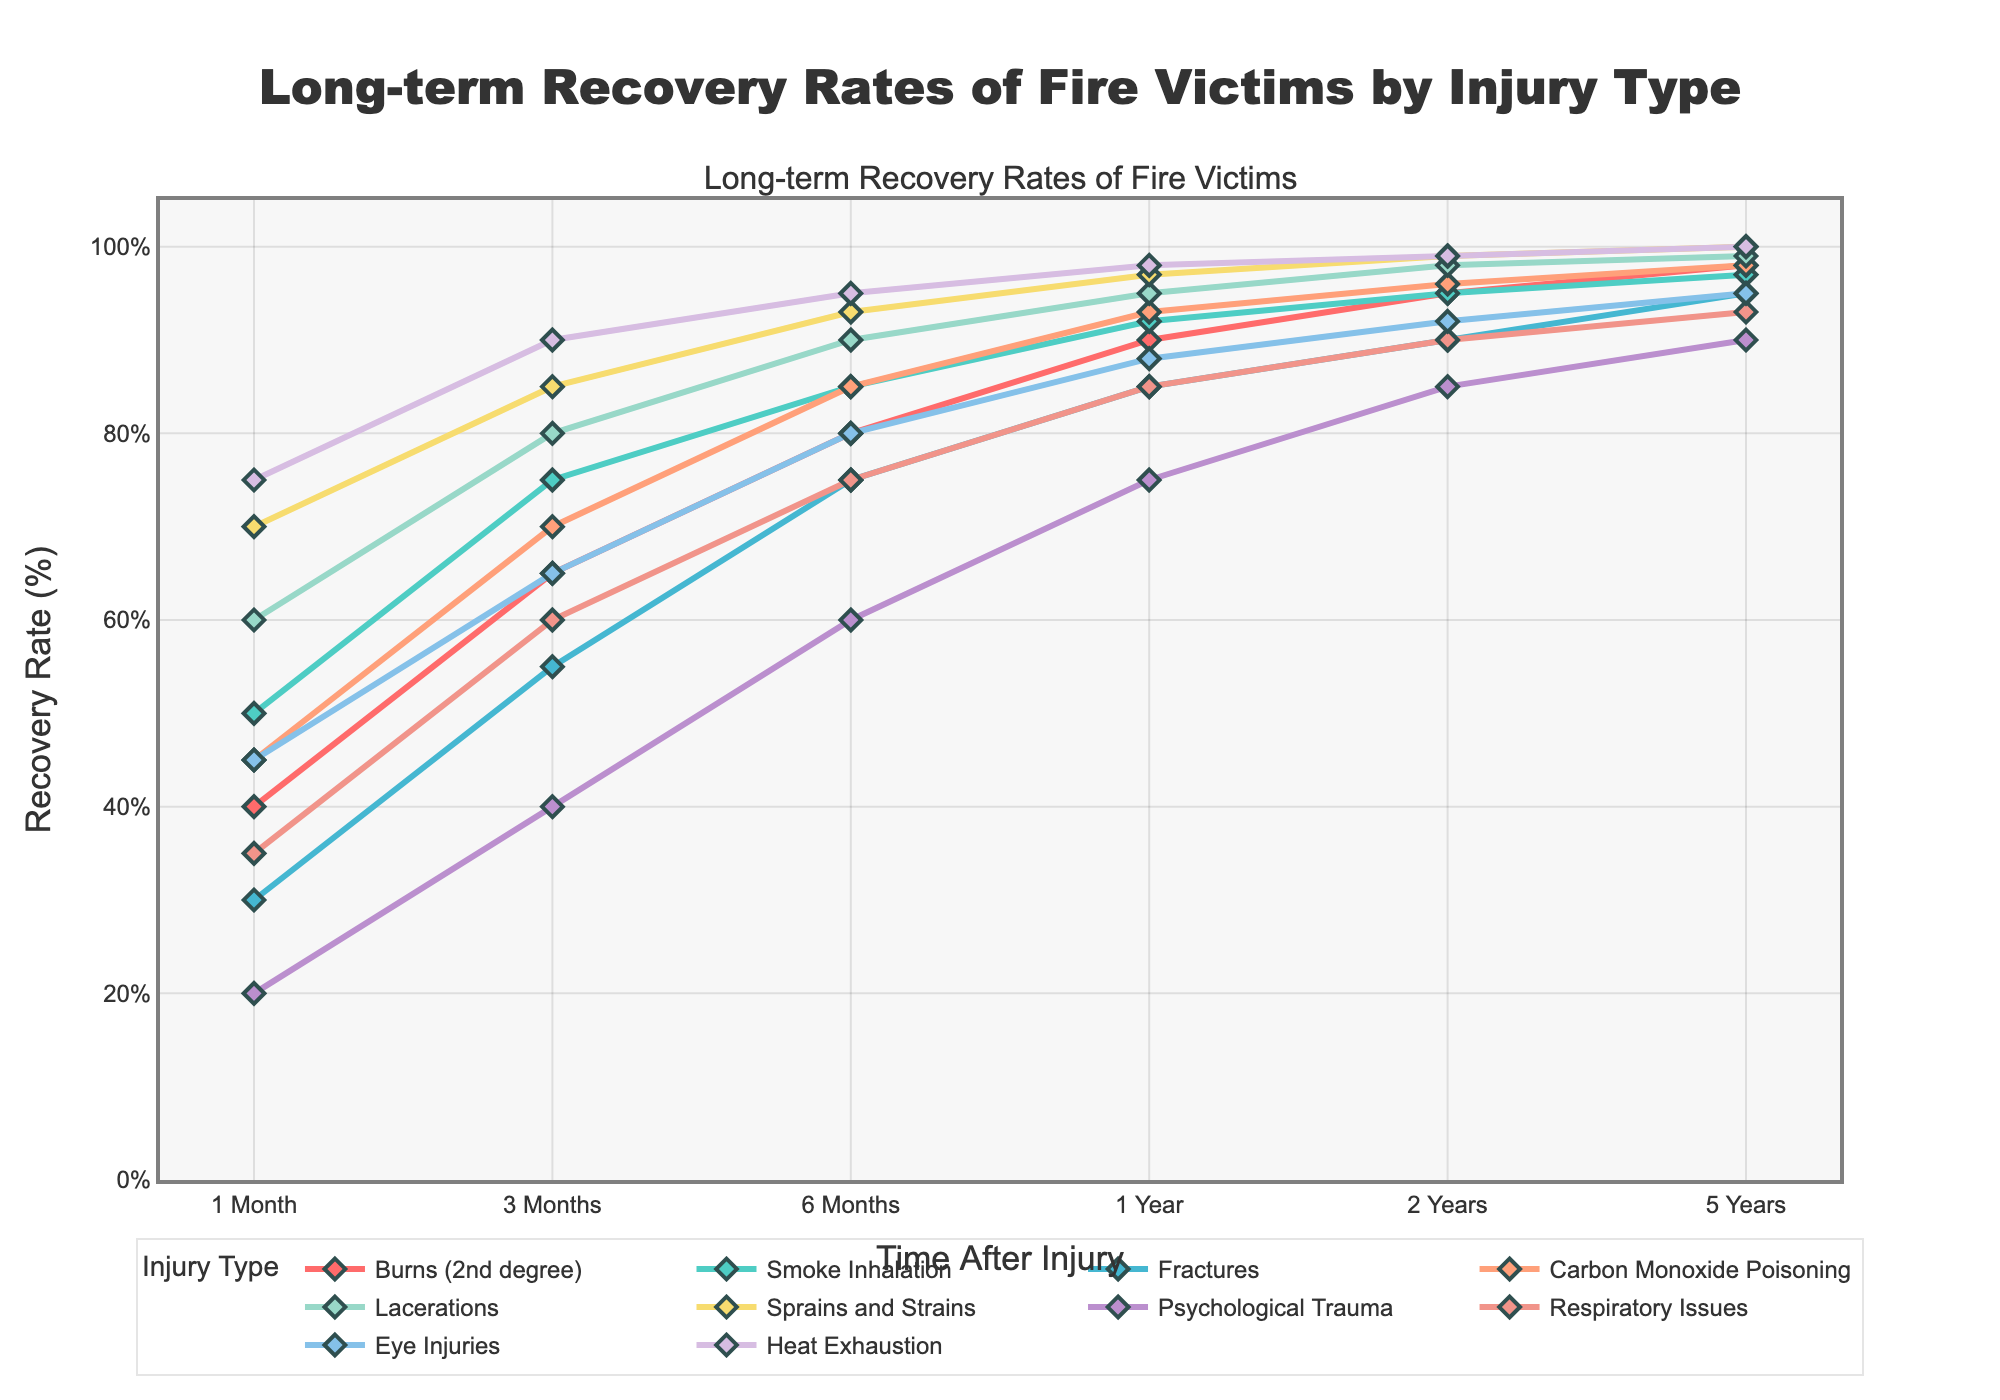What injury type shows the highest recovery rate at the 1-year mark? To answer this, look for the data point with the highest value at the 1-year time interval on the figure. Heat Exhaustion reaches the highest recovery rate at 1 year with 98%.
Answer: Heat Exhaustion Which injury type has the slowest initial recovery rate at 1 month? Find the injury type with the lowest value at the 1-month mark by comparing all the initial points on the figure. Psychological Trauma has the lowest initial recovery rate at 1 month with 20%.
Answer: Psychological Trauma By what percentage does the recovery rate of Psychological Trauma increase from the 1-month to the 1-year mark? Subtract the 1-month recovery rate (20%) from the 1-year recovery rate (75%) for Psychological Trauma to find the increase. The recovery rate increases by 75% - 20% = 55%.
Answer: 55% Which two injury types have the same recovery rate at 2 years? Identify injury types with overlapping points at the 2-year mark. Both Smoke Inhalation and Burns (2nd degree) have a recovery rate of 95% at 2 years.
Answer: Smoke Inhalation and Burns (2nd degree) Between Fractures and Respiratory Issues, which shows a greater improvement in recovery rate from 3 months to 6 months? Calculate the difference in recovery rates for both from 3 months to 6 months: Fractures increase from 55% to 75% (20% increase), while Respiratory Issues move from 60% to 75% (15% increase). Fractures show a greater improvement.
Answer: Fractures What is the difference in recovery rates between Smoke Inhalation and Eye Injuries at 5 years? Compare the 5-year recovery rates of Smoke Inhalation (97%) and Eye Injuries (95%) by subtracting the lower value from the higher value. The difference is 97% - 95% = 2%.
Answer: 2% Which injury type has the steepest slope of recovery between 3 months and 6 months? Look at the lines between 3 and 6 months for each injury type to identify which increases the fastest (steepest slope). Psychological Trauma increases from 40% to 60%, making the steepest slope of 20%.
Answer: Psychological Trauma How do the recovery rates of Lacerations and Sprains and Strains compare at the 6-month mark? Examine the recovery rates of Lacerations (90%) and Sprains and Strains (93%) at 6 months. Sprains and Strains have a higher recovery rate at 6 months.
Answer: Sprains and Strains Which injury shows a recovery rate of 100% at 5 years, and how unique is this? Identify if any line reaches 100% recovery at the 5-year mark. Heat Exhaustion and Sprains and Strains both show 100% recovery at 5 years. However, only these two injury types achieve this milestone, making it relatively unique.
Answer: Heat Exhaustion and Sprains and Strains 